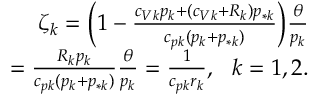<formula> <loc_0><loc_0><loc_500><loc_500>\begin{array} { r } { \zeta _ { k } = \left ( 1 - \frac { c _ { V k } p _ { k } + ( c _ { V k } + R _ { k } ) p _ { * k } } { c _ { p k } ( p _ { k } + p _ { * k } ) } \right ) \frac { \theta } { p _ { k } } } \\ { = \frac { R _ { k } p _ { k } } { c _ { p k } ( p _ { k } + p _ { * k } ) } \frac { \theta } { p _ { k } } = \frac { 1 } { c _ { p k } r _ { k } } , \ \ k = 1 , 2 . } \end{array}</formula> 